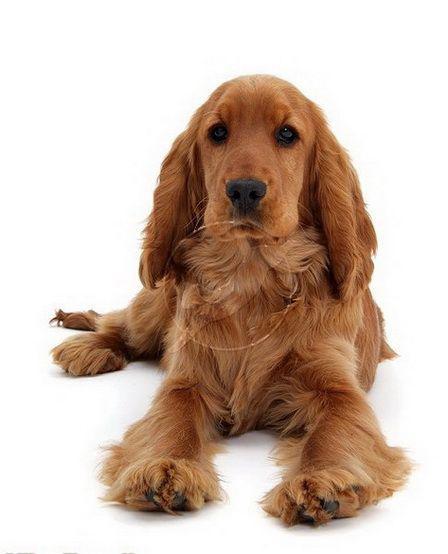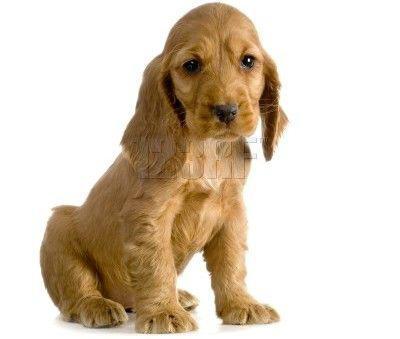The first image is the image on the left, the second image is the image on the right. For the images displayed, is the sentence "A dog has its tongue sticking out." factually correct? Answer yes or no. No. The first image is the image on the left, the second image is the image on the right. Examine the images to the left and right. Is the description "The dog in the image on the right is sitting down" accurate? Answer yes or no. Yes. 